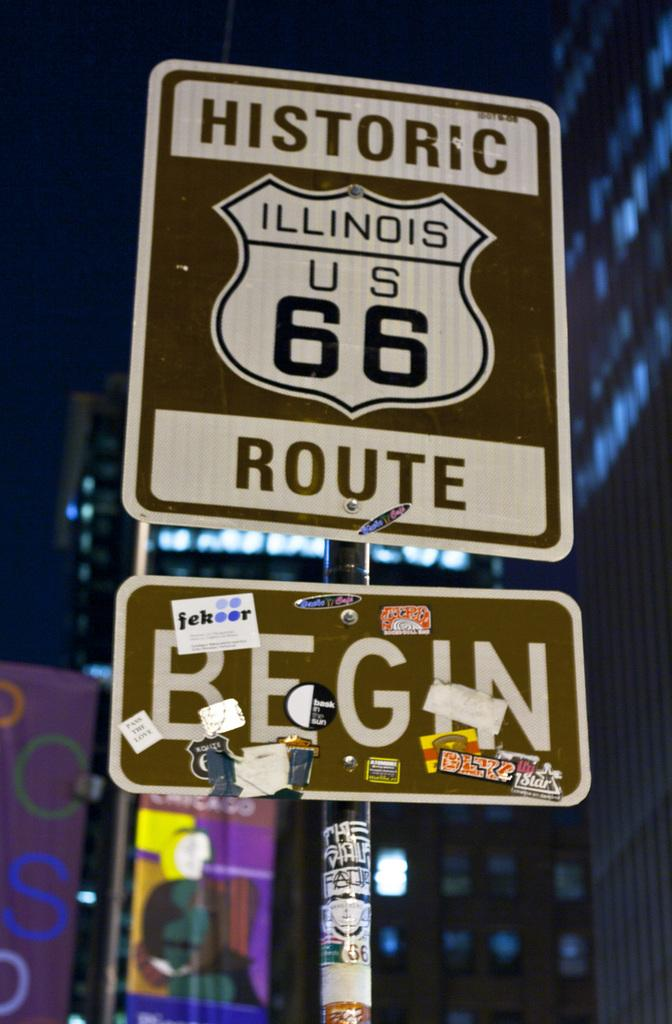<image>
Present a compact description of the photo's key features. a sign that says historic, illinois us 66, route 